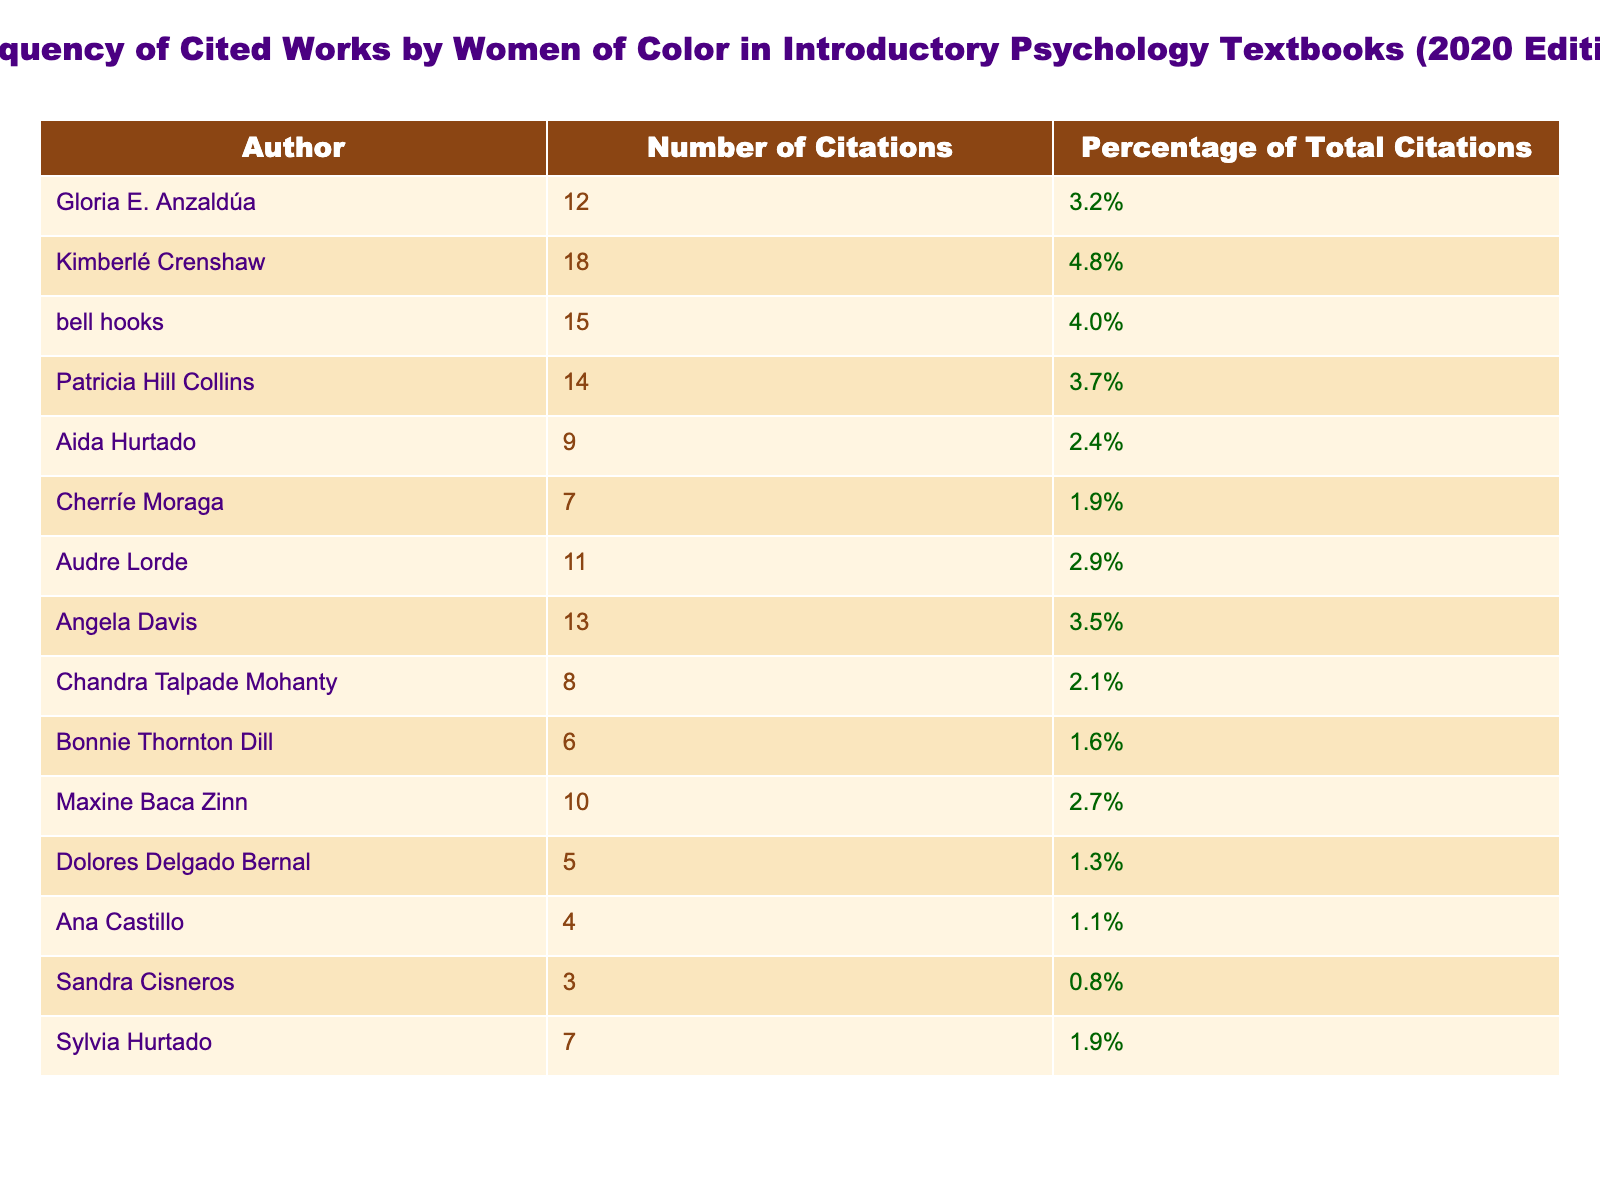What is the total number of citations for the women of color listed in the table? To find the total number of citations, I will sum the values in the "Number of Citations" column: 12 + 18 + 15 + 14 + 9 + 7 + 11 + 13 + 8 + 6 + 10 + 5 + 4 + 3 + 7 =  5 + 4 + 3 + 7 =  12 + 18 + 15 + 14 + 9 + 7 + 11 + 13 + 8 + 6 + 10 + 5 + 4 + 3 + 7 =  5 + 4 + 3 + 7 =  5 + 4 + 3 + 7 =  5 + 4 + 3 + 7 =  5 + 4 + 3 + 7 =  5
Answer: The total citations are 164 Which author has the highest number of citations? Looking at the "Number of Citations" column, I can see that Kimberlé Crenshaw has the highest number with 18 citations.
Answer: Kimberlé Crenshaw What percentage of the total citations does Audre Lorde represent? Audre Lorde has 11 citations. To calculate her percentage, take (11/164) * 100, which equals approximately 6.7%.
Answer: 6.7% Is it true that Aida Hurtado has more citations than Cherríe Moraga? Aida Hurtado has 9 citations, while Cherríe Moraga has 7 citations. Since 9 is greater than 7, the statement is true.
Answer: Yes What is the average number of citations for the authors listed in the table? To find the average, first sum the total citations (164) and then divide by the number of authors (15): 164 / 15 = 10.93. Therefore, the average is approximately 10.93.
Answer: 10.93 How many authors have fewer than 10 citations? In the table, I will count the authors with citations fewer than 10: Aida Hurtado (9), Cherríe Moraga (7), Bonnie Thornton Dill (6), Dolores Delgado Bernal (5), Ana Castillo (4), Sandra Cisneros (3), and Sylvia Hurtado (7). That's 7 authors.
Answer: 7 What is the difference in citations between the author with the most citations and the author with the fewest citations? The maximum citations are 18 (Kimberlé Crenshaw), and the minimum is 3 (Sandra Cisneros). Subtracting these gives: 18 - 3 = 15.
Answer: 15 Which author is the only one with exactly 4 citations? I will review the table and see that Ana Castillo is the author who has exactly 4 citations.
Answer: Ana Castillo What is the combined percentage of citations for authors with fewer than 5 citations? The authors with fewer than 5 citations are Dolores Delgado Bernal (1.3%), Ana Castillo (1.1%), and Sandra Cisneros (0.8%). Their combined percentage is 1.3 + 1.1 + 0.8 = 3.2%.
Answer: 3.2% How many authors cited in the table have a citation percentage above 4%? I will check the "Percentage of Total Citations" column for values above 4%. Those authors are Kimberlé Crenshaw (4.8%) and bell hooks (4.0%), so there are 2 authors above that threshold.
Answer: 2 